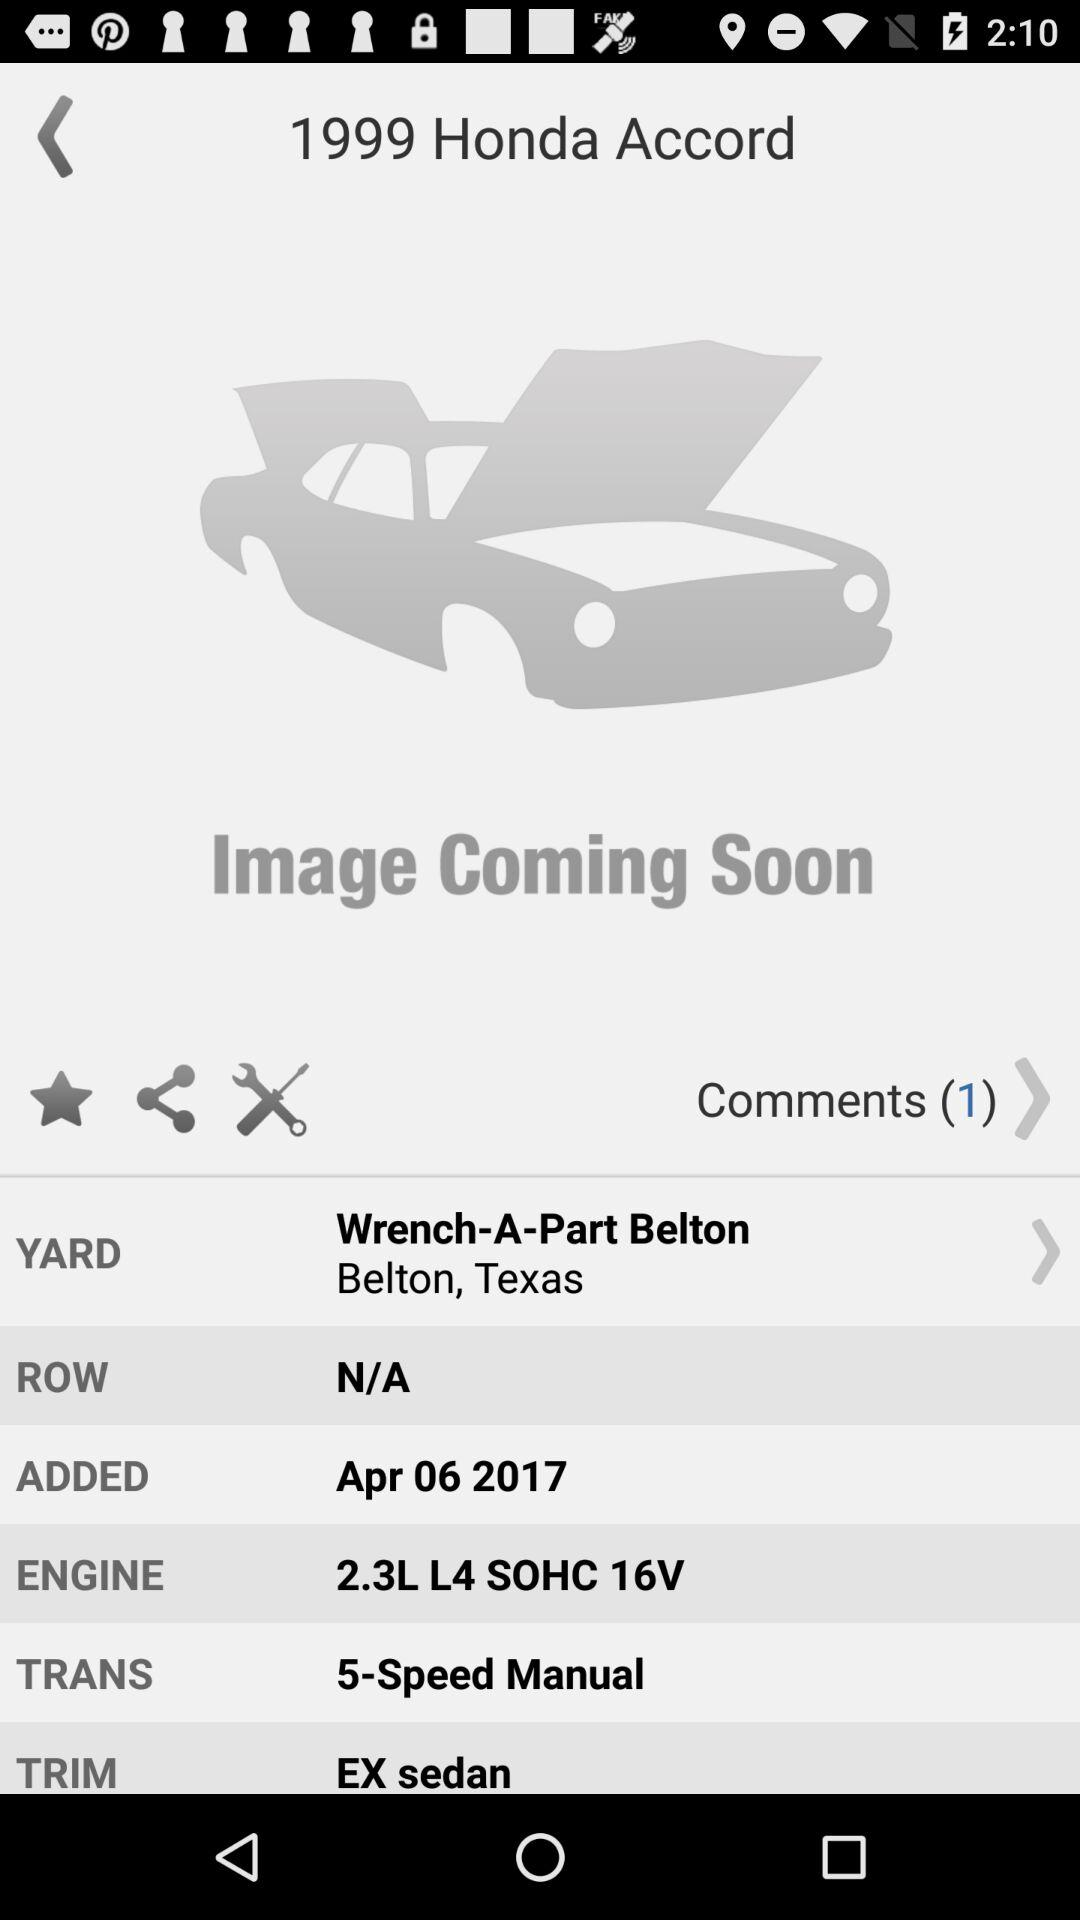What is the year of the vehicle? The vehicle displayed is a 1999 model year. An interesting fact to note is that the 1999 Honda Accord models were part of the sixth generation, renowned for their reliability and were available with several engine options, including the 2.3L inline-four engine shown on this image's details. 